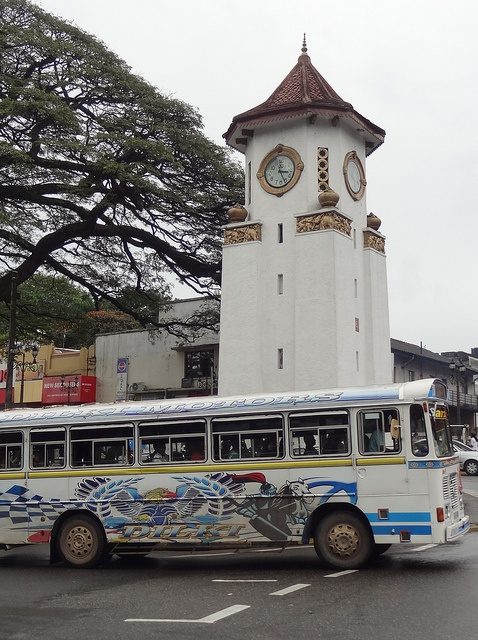Describe the objects in this image and their specific colors. I can see bus in gray, black, darkgray, and lightgray tones, clock in gray and darkgray tones, clock in gray, darkgray, and black tones, car in gray, darkgray, black, and lightgray tones, and people in gray and black tones in this image. 